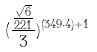Convert formula to latex. <formula><loc_0><loc_0><loc_500><loc_500>( \frac { \frac { \sqrt { 6 } } { 2 2 1 } } { 3 } ) ^ { ( 3 4 9 \cdot 4 ) + 1 }</formula> 